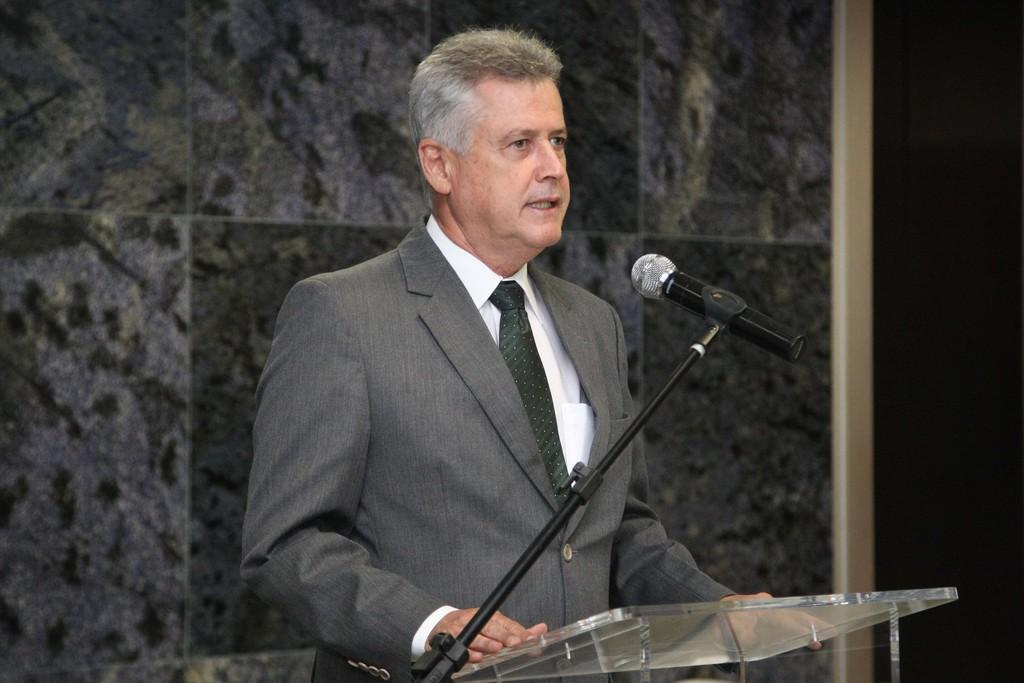What is the person in the image doing? The person is standing in front of a podium. What object is present for the person to use for speaking? There is a microphone (mic) in the image. What can be seen behind the person? There is a wall in the background of the image. What type of jewel can be seen hanging from the swing in the image? There is no swing or jewel present in the image. 